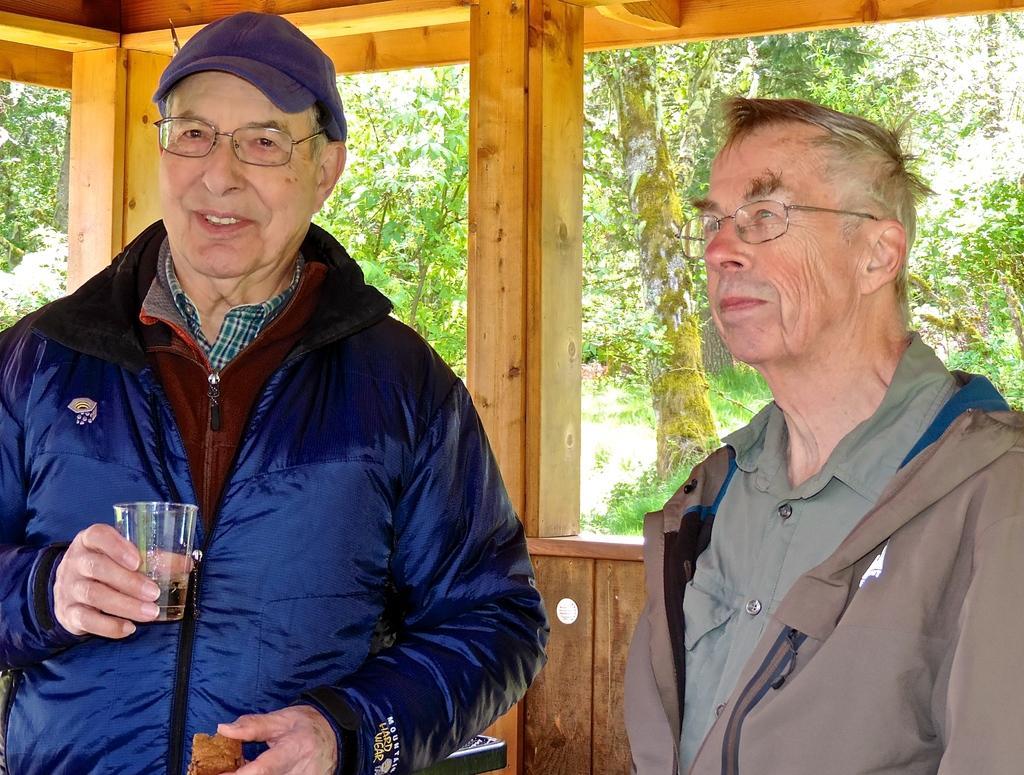Could you give a brief overview of what you see in this image? This image is taken indoors. In the background there are a few trees and plants on the ground. There is a wooden wall. On the left side of the image a man is standing and he is holding a glass of wine and a food item in his hands. He is with a smiling face. On the right side of the image a man is standing. 